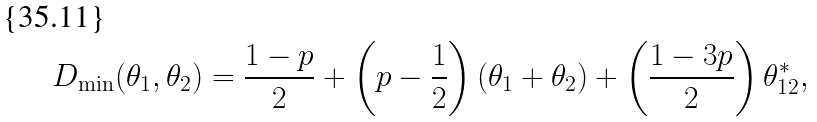Convert formula to latex. <formula><loc_0><loc_0><loc_500><loc_500>D _ { \min } ( \theta _ { 1 } , \theta _ { 2 } ) = \frac { 1 - p } { 2 } + \left ( p - \frac { 1 } { 2 } \right ) ( \theta _ { 1 } + \theta _ { 2 } ) + \left ( \frac { 1 - 3 p } { 2 } \right ) \theta _ { 1 2 } ^ { * } ,</formula> 